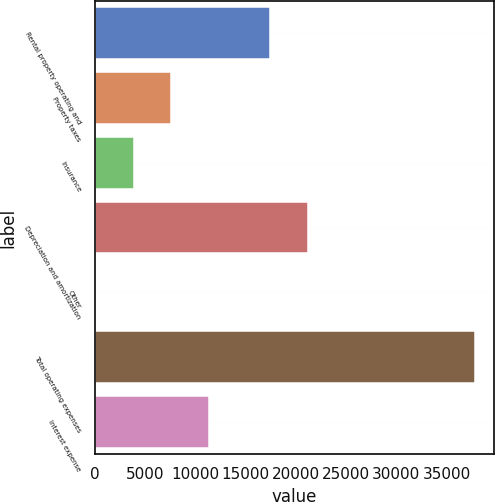Convert chart to OTSL. <chart><loc_0><loc_0><loc_500><loc_500><bar_chart><fcel>Rental property operating and<fcel>Property taxes<fcel>Insurance<fcel>Depreciation and amortization<fcel>Other<fcel>Total operating expenses<fcel>Interest expense<nl><fcel>17453<fcel>7632.4<fcel>3856.2<fcel>21229.2<fcel>80<fcel>37842<fcel>11408.6<nl></chart> 